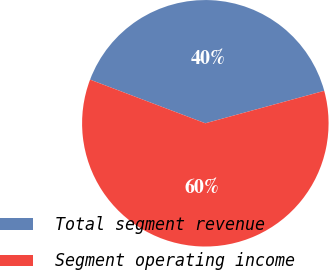<chart> <loc_0><loc_0><loc_500><loc_500><pie_chart><fcel>Total segment revenue<fcel>Segment operating income<nl><fcel>40.0%<fcel>60.0%<nl></chart> 